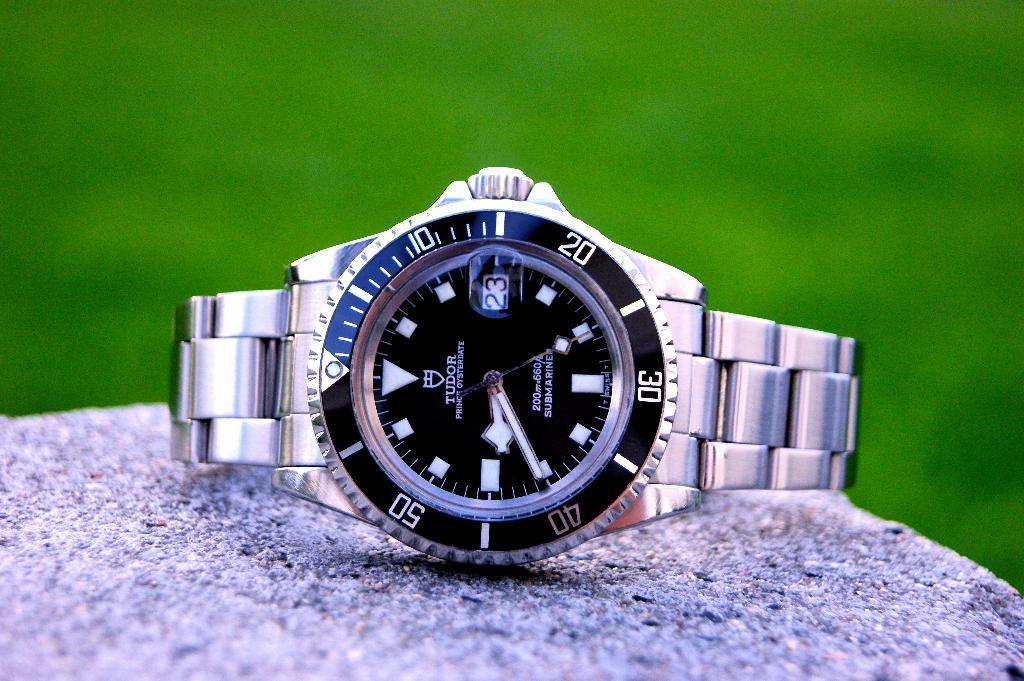Provide a one-sentence caption for the provided image. SIlver and black wristwatch which says TUDOR on it. 